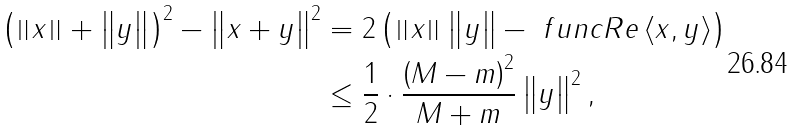Convert formula to latex. <formula><loc_0><loc_0><loc_500><loc_500>\left ( \left \| x \right \| + \left \| y \right \| \right ) ^ { 2 } - \left \| x + y \right \| ^ { 2 } & = 2 \left ( \left \| x \right \| \left \| y \right \| - \ f u n c { R e } \left \langle x , y \right \rangle \right ) \\ & \leq \frac { 1 } { 2 } \cdot \frac { \left ( M - m \right ) ^ { 2 } } { M + m } \left \| y \right \| ^ { 2 } ,</formula> 